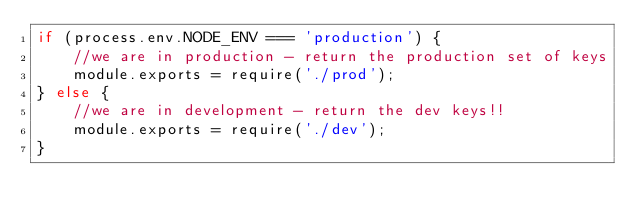Convert code to text. <code><loc_0><loc_0><loc_500><loc_500><_JavaScript_>if (process.env.NODE_ENV === 'production') {
	//we are in production - return the production set of keys
	module.exports = require('./prod');
} else {
	//we are in development - return the dev keys!!
	module.exports = require('./dev');
}
</code> 